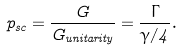Convert formula to latex. <formula><loc_0><loc_0><loc_500><loc_500>p _ { s c } = \frac { G } { G _ { u n i t a r i t y } } = \frac { \Gamma } { \gamma / 4 } .</formula> 